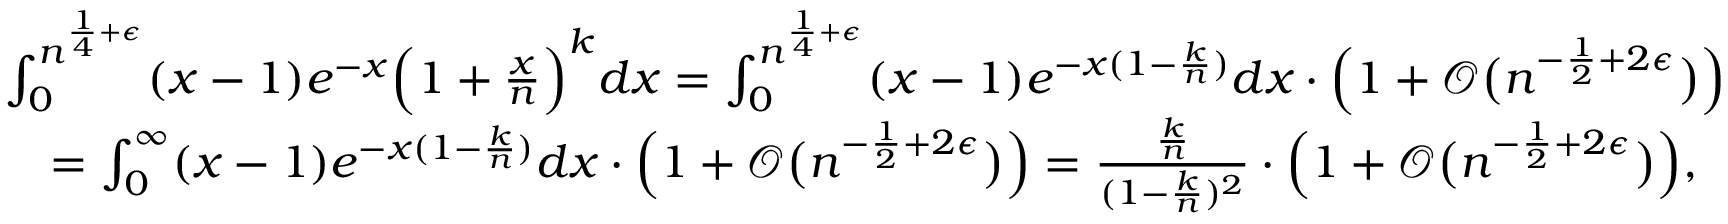Convert formula to latex. <formula><loc_0><loc_0><loc_500><loc_500>\begin{array} { r l } & { \int _ { 0 } ^ { n ^ { \frac { 1 } { 4 } + \epsilon } } ( x - 1 ) e ^ { - x } \left ( 1 + \frac { x } { n } \right ) ^ { k } d x = \int _ { 0 } ^ { n ^ { \frac { 1 } { 4 } + \epsilon } } ( x - 1 ) e ^ { - x ( 1 - \frac { k } { n } ) } d x \cdot \left ( 1 + \mathcal { O } \left ( n ^ { - \frac { 1 } { 2 } + 2 \epsilon } \right ) \right ) } \\ & { \quad = \int _ { 0 } ^ { \infty } ( x - 1 ) e ^ { - x ( 1 - \frac { k } { n } ) } d x \cdot \left ( 1 + \mathcal { O } \left ( n ^ { - \frac { 1 } { 2 } + 2 \epsilon } \right ) \right ) = \frac { \frac { k } { n } } { ( 1 - \frac { k } { n } ) ^ { 2 } } \cdot \left ( 1 + \mathcal { O } \left ( n ^ { - \frac { 1 } { 2 } + 2 \epsilon } \right ) \right ) , } \end{array}</formula> 